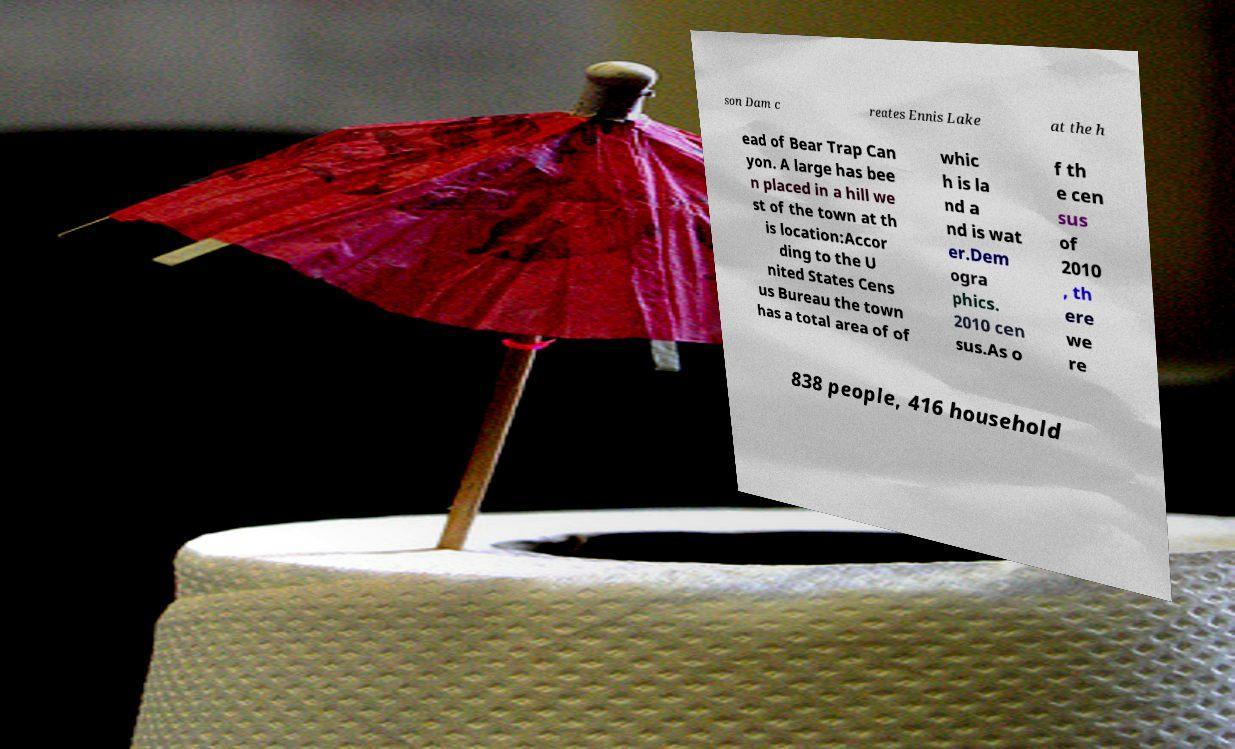Can you accurately transcribe the text from the provided image for me? son Dam c reates Ennis Lake at the h ead of Bear Trap Can yon. A large has bee n placed in a hill we st of the town at th is location:Accor ding to the U nited States Cens us Bureau the town has a total area of of whic h is la nd a nd is wat er.Dem ogra phics. 2010 cen sus.As o f th e cen sus of 2010 , th ere we re 838 people, 416 household 